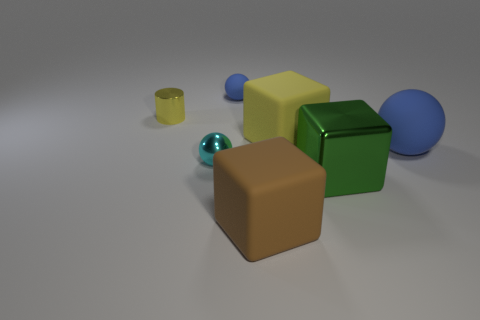Is there anything else that has the same shape as the tiny yellow object?
Ensure brevity in your answer.  No. There is a matte sphere that is behind the matte cube that is behind the cyan ball; how big is it?
Your response must be concise. Small. Is the material of the big green object the same as the cyan sphere on the left side of the large yellow block?
Provide a succinct answer. Yes. Are there fewer tiny balls in front of the small blue matte ball than big rubber things that are behind the big brown block?
Your answer should be compact. Yes. There is a small sphere that is made of the same material as the green thing; what is its color?
Provide a short and direct response. Cyan. Is there a yellow object on the left side of the blue rubber thing left of the big green metallic cube?
Provide a succinct answer. Yes. There is a matte sphere that is the same size as the green object; what color is it?
Your response must be concise. Blue. How many objects are either large cylinders or small metal objects?
Provide a succinct answer. 2. There is a yellow thing that is left of the blue matte ball behind the rubber cube behind the brown rubber block; what size is it?
Keep it short and to the point. Small. How many large things have the same color as the small matte object?
Keep it short and to the point. 1. 